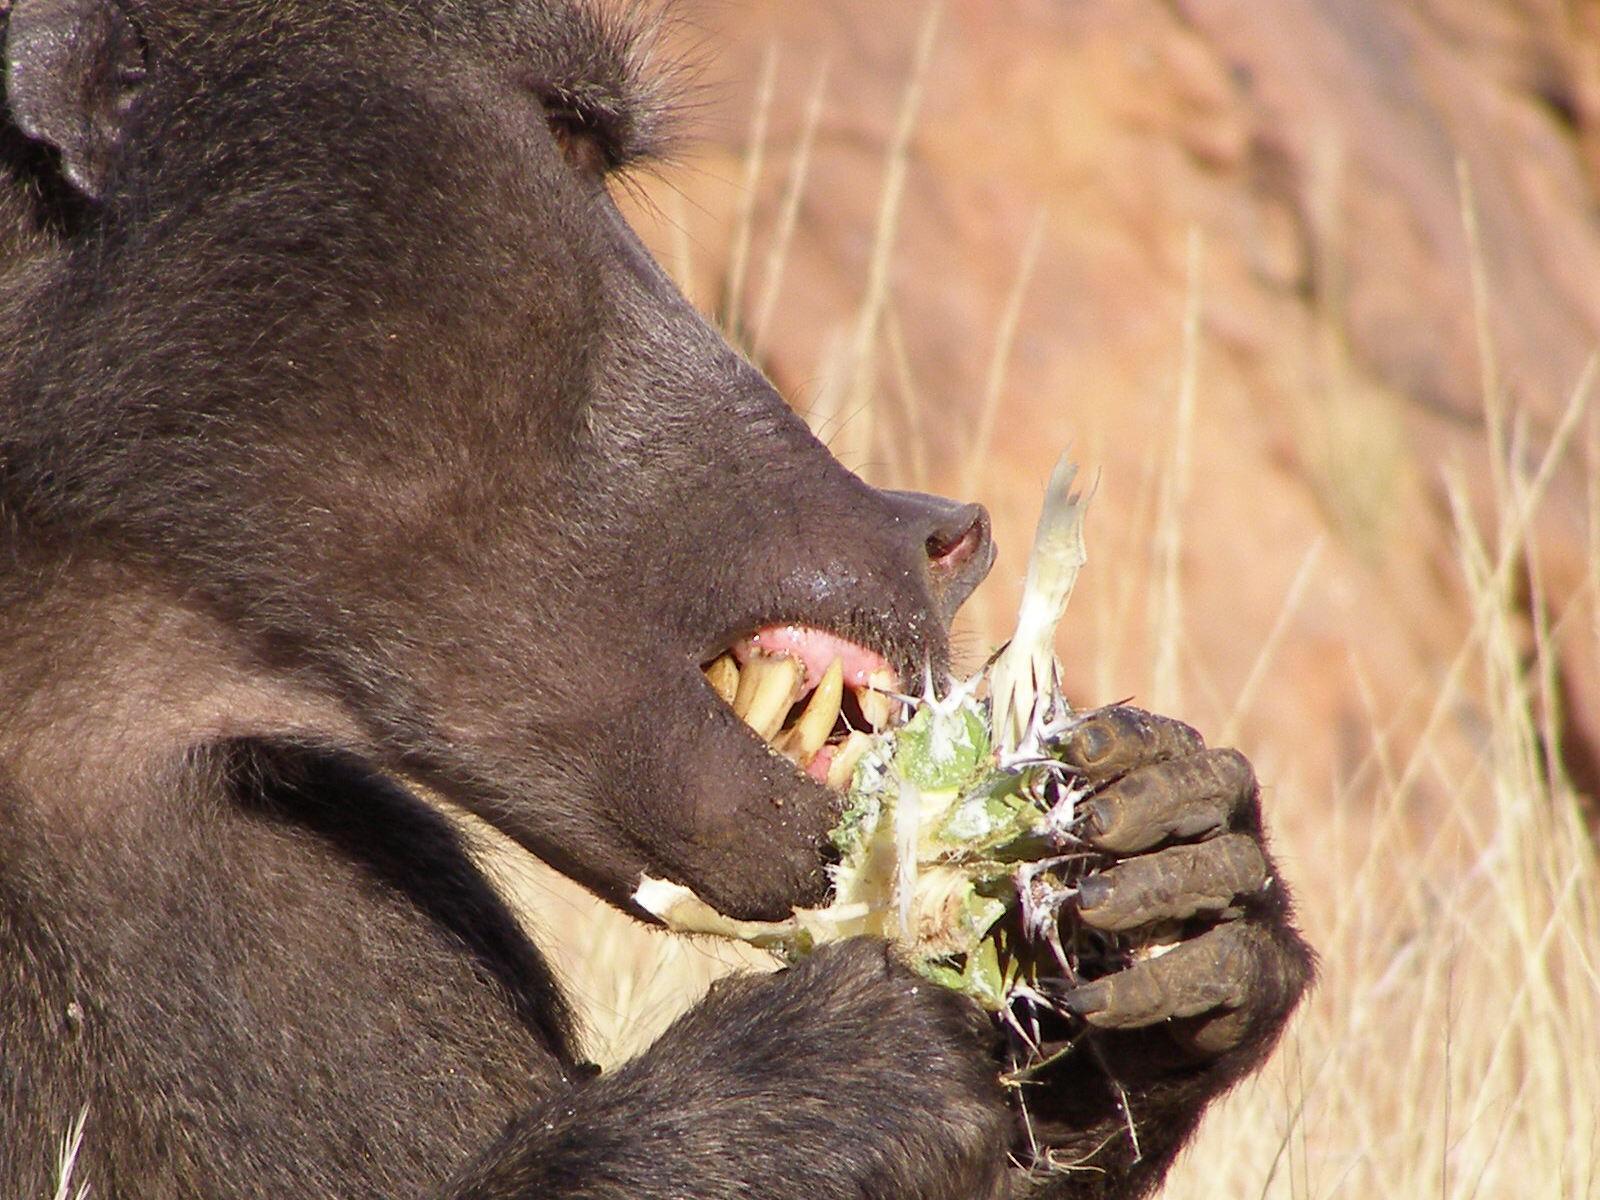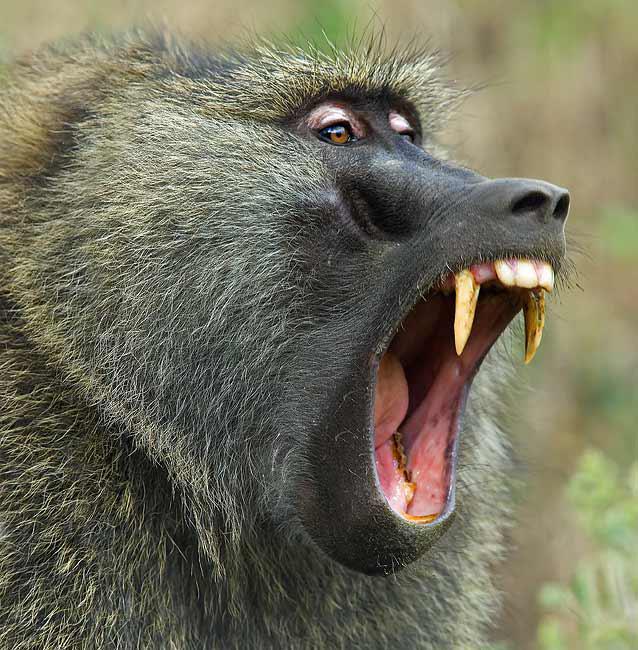The first image is the image on the left, the second image is the image on the right. Evaluate the accuracy of this statement regarding the images: "At least one monkey has its mouth wide open with sharp teeth visible.". Is it true? Answer yes or no. Yes. The first image is the image on the left, the second image is the image on the right. Given the left and right images, does the statement "An image show a right-facing monkey with wide-opened mouth baring its fangs." hold true? Answer yes or no. Yes. 